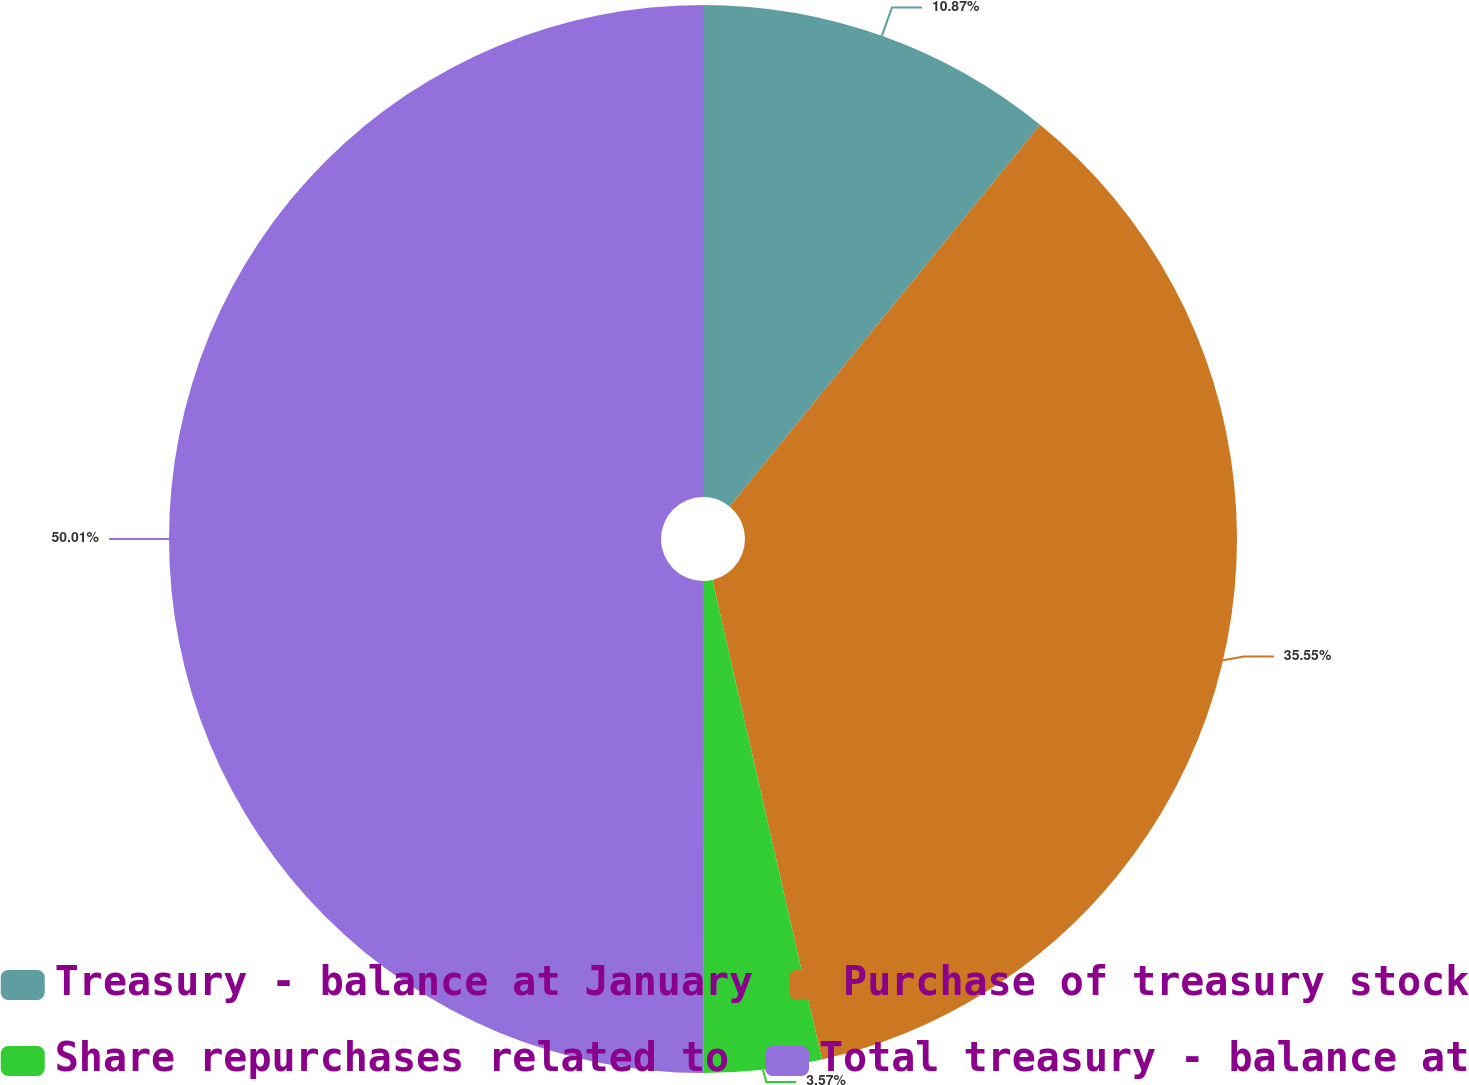Convert chart. <chart><loc_0><loc_0><loc_500><loc_500><pie_chart><fcel>Treasury - balance at January<fcel>Purchase of treasury stock<fcel>Share repurchases related to<fcel>Total treasury - balance at<nl><fcel>10.87%<fcel>35.55%<fcel>3.57%<fcel>50.0%<nl></chart> 